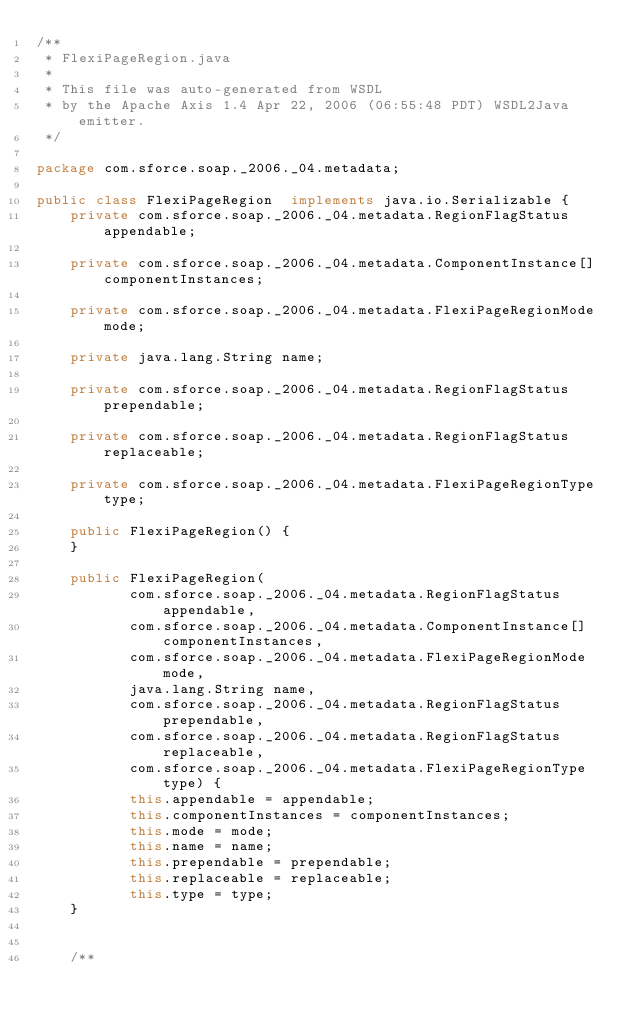<code> <loc_0><loc_0><loc_500><loc_500><_Java_>/**
 * FlexiPageRegion.java
 *
 * This file was auto-generated from WSDL
 * by the Apache Axis 1.4 Apr 22, 2006 (06:55:48 PDT) WSDL2Java emitter.
 */

package com.sforce.soap._2006._04.metadata;

public class FlexiPageRegion  implements java.io.Serializable {
    private com.sforce.soap._2006._04.metadata.RegionFlagStatus appendable;

    private com.sforce.soap._2006._04.metadata.ComponentInstance[] componentInstances;

    private com.sforce.soap._2006._04.metadata.FlexiPageRegionMode mode;

    private java.lang.String name;

    private com.sforce.soap._2006._04.metadata.RegionFlagStatus prependable;

    private com.sforce.soap._2006._04.metadata.RegionFlagStatus replaceable;

    private com.sforce.soap._2006._04.metadata.FlexiPageRegionType type;

    public FlexiPageRegion() {
    }

    public FlexiPageRegion(
           com.sforce.soap._2006._04.metadata.RegionFlagStatus appendable,
           com.sforce.soap._2006._04.metadata.ComponentInstance[] componentInstances,
           com.sforce.soap._2006._04.metadata.FlexiPageRegionMode mode,
           java.lang.String name,
           com.sforce.soap._2006._04.metadata.RegionFlagStatus prependable,
           com.sforce.soap._2006._04.metadata.RegionFlagStatus replaceable,
           com.sforce.soap._2006._04.metadata.FlexiPageRegionType type) {
           this.appendable = appendable;
           this.componentInstances = componentInstances;
           this.mode = mode;
           this.name = name;
           this.prependable = prependable;
           this.replaceable = replaceable;
           this.type = type;
    }


    /**</code> 